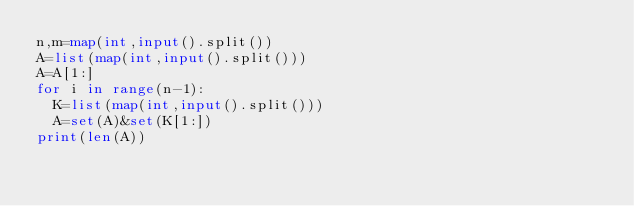<code> <loc_0><loc_0><loc_500><loc_500><_Python_>n,m=map(int,input().split())
A=list(map(int,input().split()))
A=A[1:]
for i in range(n-1):
  K=list(map(int,input().split()))
  A=set(A)&set(K[1:])
print(len(A))</code> 